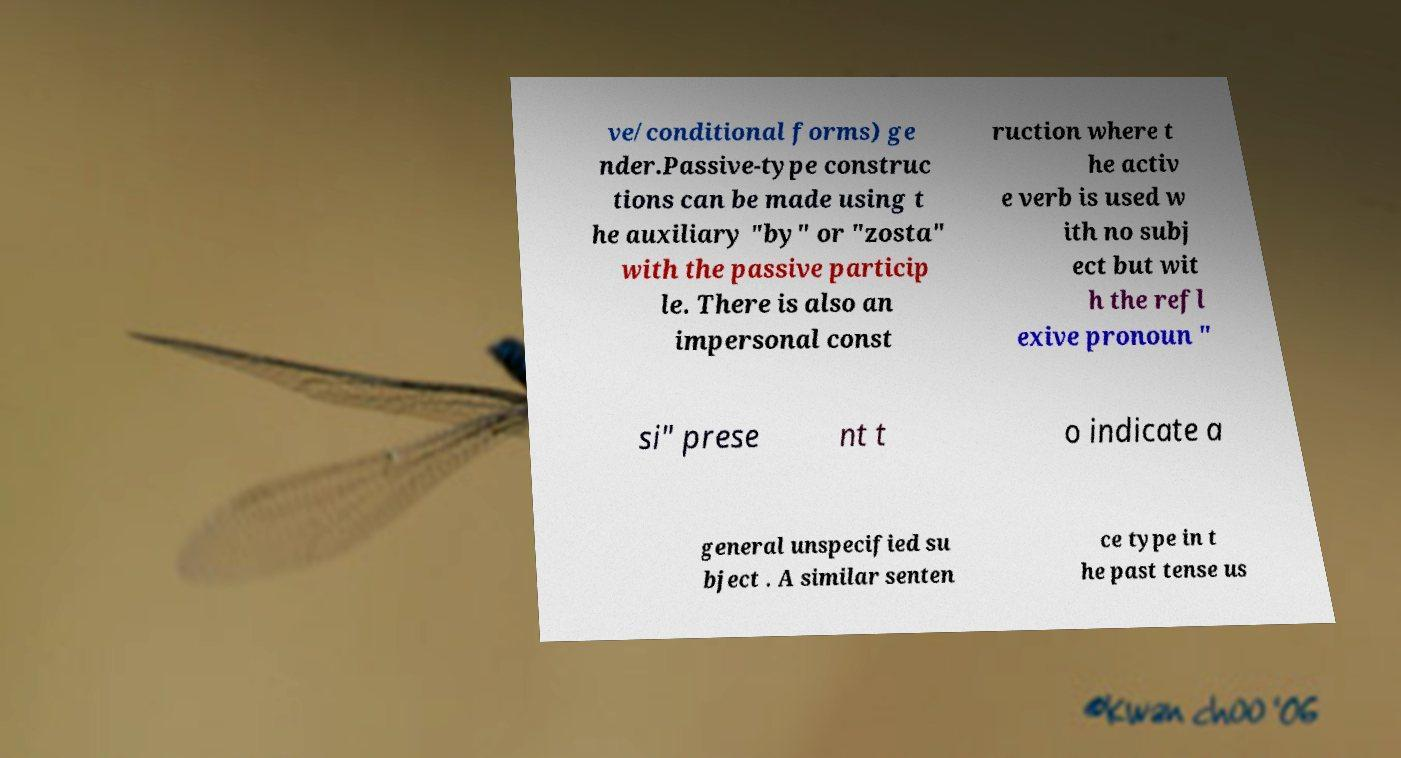Please identify and transcribe the text found in this image. ve/conditional forms) ge nder.Passive-type construc tions can be made using t he auxiliary "by" or "zosta" with the passive particip le. There is also an impersonal const ruction where t he activ e verb is used w ith no subj ect but wit h the refl exive pronoun " si" prese nt t o indicate a general unspecified su bject . A similar senten ce type in t he past tense us 